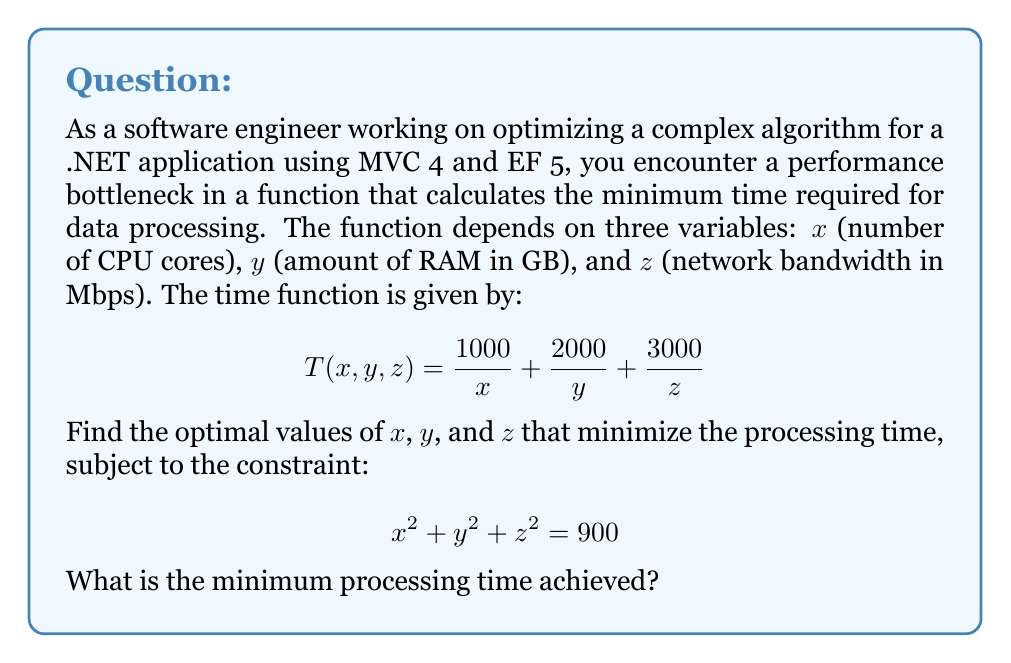Show me your answer to this math problem. To solve this optimization problem with a constraint, we'll use the method of Lagrange multipliers:

1) Define the Lagrangian function:
   $$L(x,y,z,\lambda) = T(x,y,z) - \lambda(x^2 + y^2 + z^2 - 900)$$
   $$L(x,y,z,\lambda) = \frac{1000}{x} + \frac{2000}{y} + \frac{3000}{z} - \lambda(x^2 + y^2 + z^2 - 900)$$

2) Take partial derivatives and set them to zero:
   $$\frac{\partial L}{\partial x} = -\frac{1000}{x^2} - 2\lambda x = 0$$
   $$\frac{\partial L}{\partial y} = -\frac{2000}{y^2} - 2\lambda y = 0$$
   $$\frac{\partial L}{\partial z} = -\frac{3000}{z^2} - 2\lambda z = 0$$
   $$\frac{\partial L}{\partial \lambda} = x^2 + y^2 + z^2 - 900 = 0$$

3) From the first three equations:
   $$x^3 = \frac{500}{\lambda}, y^3 = \frac{1000}{\lambda}, z^3 = \frac{1500}{\lambda}$$

4) Substitute these into the constraint equation:
   $$(\frac{500}{\lambda})^{2/3} + (\frac{1000}{\lambda})^{2/3} + (\frac{1500}{\lambda})^{2/3} = 900$$

5) Simplify:
   $$\frac{1}{\lambda^{2/3}}(5^{2/3} + 10^{2/3} + 15^{2/3}) = 900$$

6) Solve for $\lambda$:
   $$\lambda = \frac{(5^{2/3} + 10^{2/3} + 15^{2/3})^{3/2}}{900^{3/2}} \approx 0.001851$$

7) Calculate $x$, $y$, and $z$:
   $$x = (\frac{500}{\lambda})^{1/3} \approx 10$$
   $$y = (\frac{1000}{\lambda})^{1/3} \approx 12.6$$
   $$z = (\frac{1500}{\lambda})^{1/3} \approx 14.4$$

8) Calculate the minimum processing time:
   $$T_{min} = \frac{1000}{10} + \frac{2000}{12.6} + \frac{3000}{14.4} \approx 100 + 158.7 + 208.3 = 467$$
Answer: 467 (units of time) 